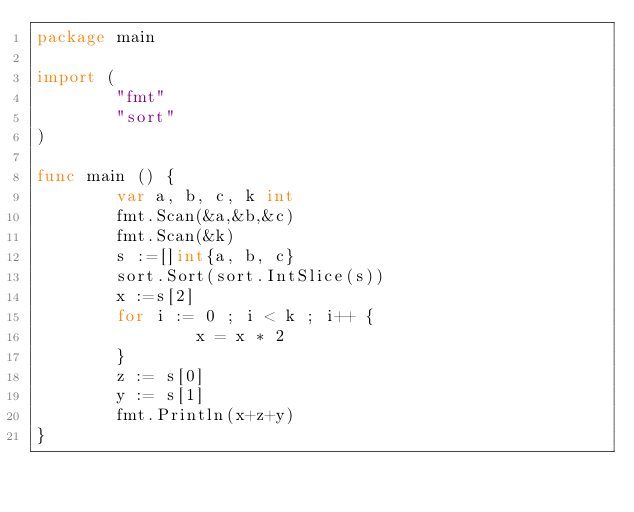<code> <loc_0><loc_0><loc_500><loc_500><_Go_>package main 

import (
        "fmt"
        "sort"
)

func main () {
        var a, b, c, k int
        fmt.Scan(&a,&b,&c)
        fmt.Scan(&k)
        s :=[]int{a, b, c}
        sort.Sort(sort.IntSlice(s))
        x :=s[2]
        for i := 0 ; i < k ; i++ {
                x = x * 2
        }
        z := s[0]
        y := s[1]
        fmt.Println(x+z+y)
}
</code> 